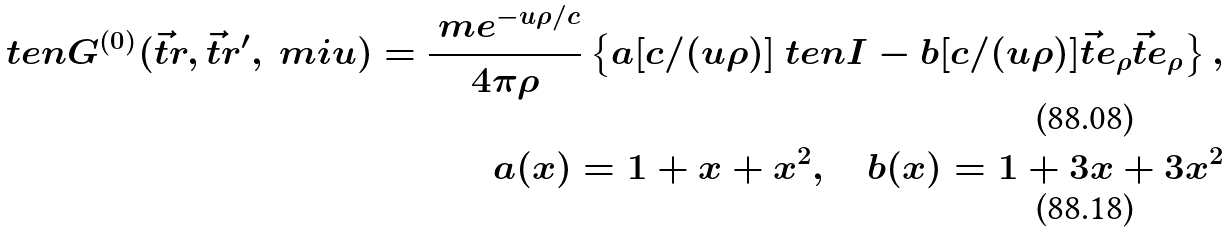Convert formula to latex. <formula><loc_0><loc_0><loc_500><loc_500>\ t e n { G } ^ { ( 0 ) } ( \vec { t } { r } , \vec { t } { r } ^ { \prime } , \ m i u ) = \frac { \ m e ^ { - u \rho / c } } { 4 \pi \rho } \left \{ a [ c / ( u \rho ) ] \ t e n { I } - b [ c / ( u \rho ) ] \vec { t } { e } _ { \rho } \vec { t } { e } _ { \rho } \right \} , \\ a ( x ) = 1 + x + x ^ { 2 } , \quad b ( x ) = 1 + 3 x + 3 x ^ { 2 }</formula> 